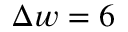<formula> <loc_0><loc_0><loc_500><loc_500>\Delta w = 6</formula> 